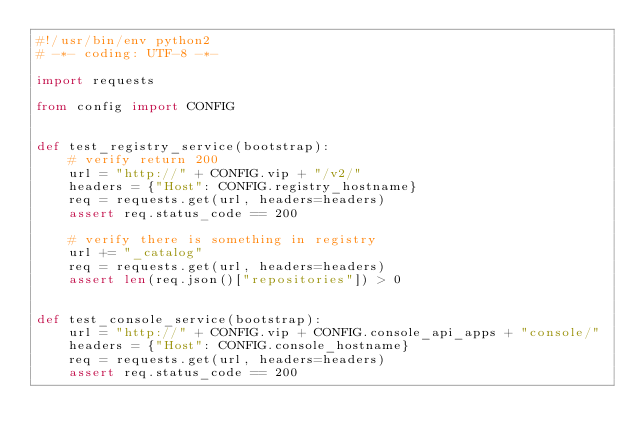Convert code to text. <code><loc_0><loc_0><loc_500><loc_500><_Python_>#!/usr/bin/env python2
# -*- coding: UTF-8 -*-

import requests

from config import CONFIG


def test_registry_service(bootstrap):
    # verify return 200
    url = "http://" + CONFIG.vip + "/v2/"
    headers = {"Host": CONFIG.registry_hostname}
    req = requests.get(url, headers=headers)
    assert req.status_code == 200

    # verify there is something in registry
    url += "_catalog"
    req = requests.get(url, headers=headers)
    assert len(req.json()["repositories"]) > 0


def test_console_service(bootstrap):
    url = "http://" + CONFIG.vip + CONFIG.console_api_apps + "console/"
    headers = {"Host": CONFIG.console_hostname}
    req = requests.get(url, headers=headers)
    assert req.status_code == 200
</code> 